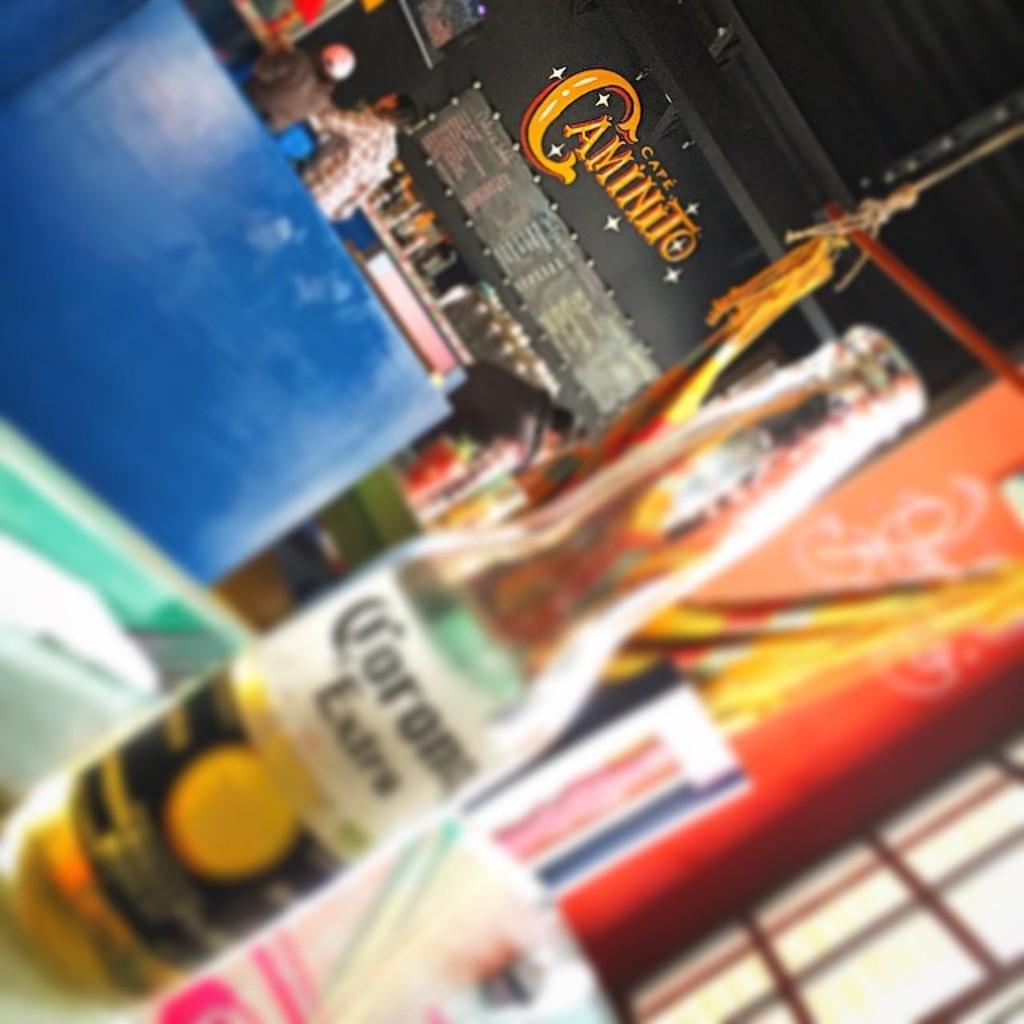What brand of beer is in the bottle?
Ensure brevity in your answer.  Corona. What is the cafe's name?
Make the answer very short. Caminito. 